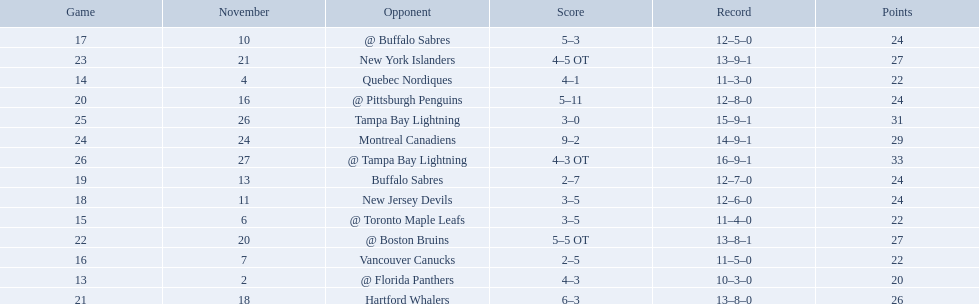What are the teams in the atlantic division? Quebec Nordiques, Vancouver Canucks, New Jersey Devils, Buffalo Sabres, Hartford Whalers, New York Islanders, Montreal Canadiens, Tampa Bay Lightning. Which of those scored fewer points than the philadelphia flyers? Tampa Bay Lightning. 